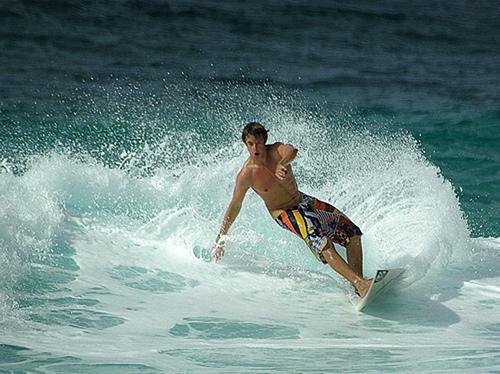How many people in the water?
Give a very brief answer. 1. 